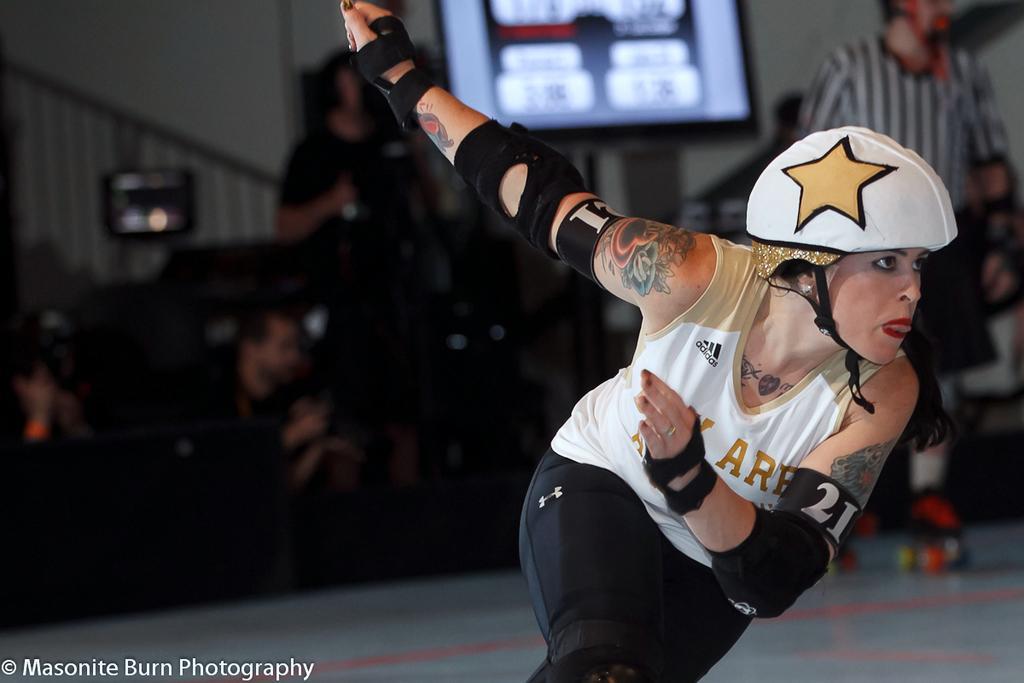Please provide a concise description of this image. In this image a girl wearing helmet is skating. Here another person wearing skating shoes. In the background there are few people. This is a screen. This is the wall. 